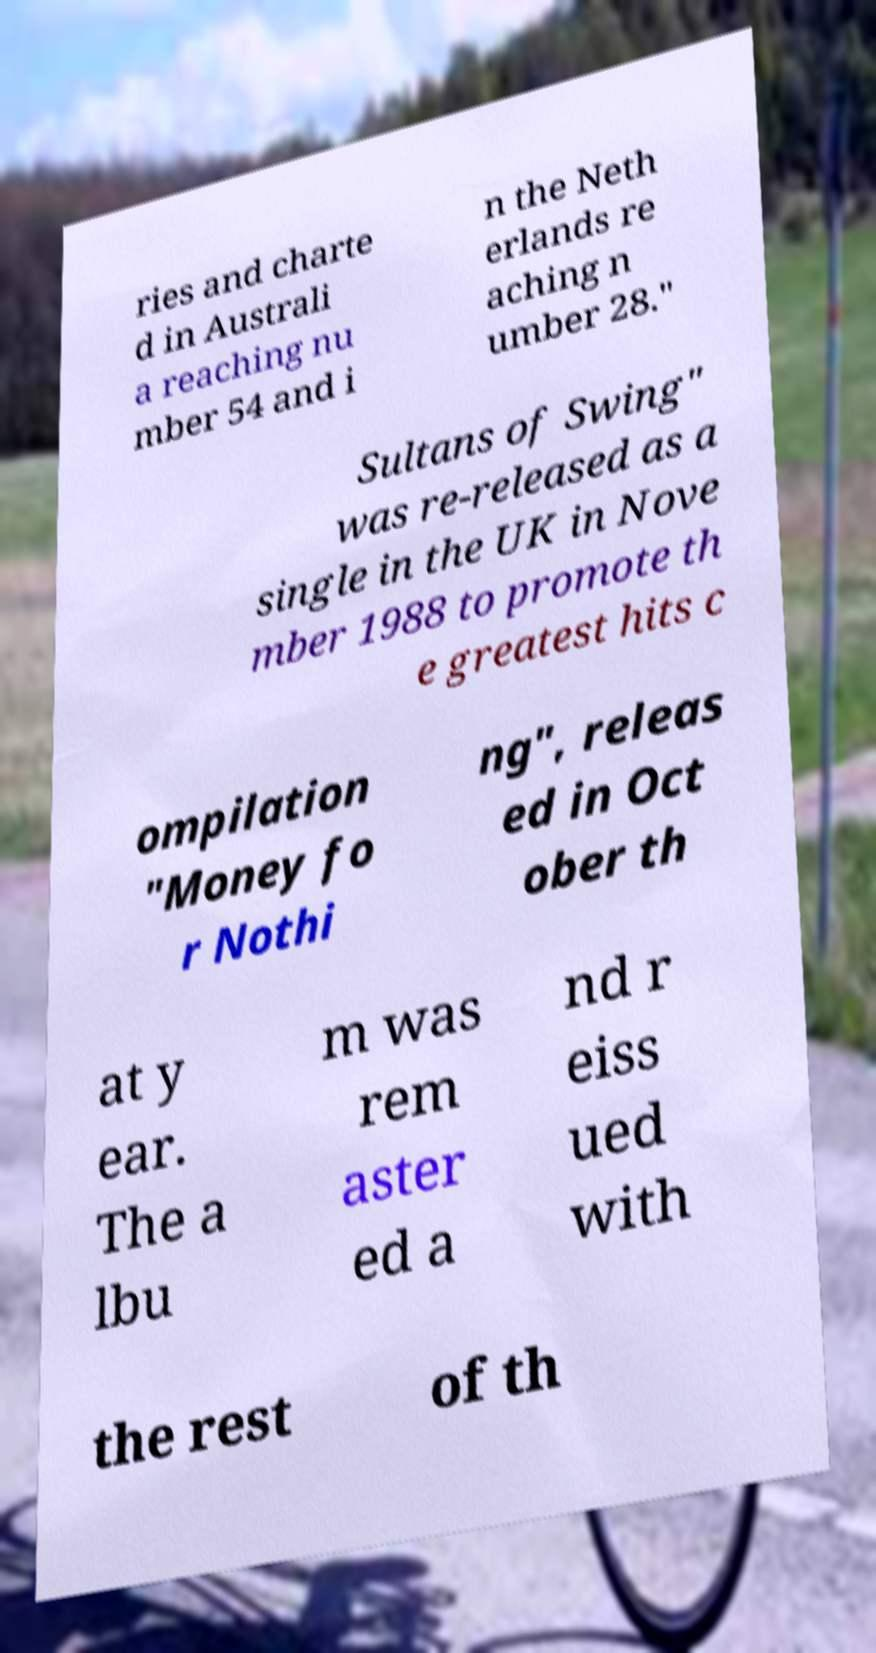Could you extract and type out the text from this image? ries and charte d in Australi a reaching nu mber 54 and i n the Neth erlands re aching n umber 28." Sultans of Swing" was re-released as a single in the UK in Nove mber 1988 to promote th e greatest hits c ompilation "Money fo r Nothi ng", releas ed in Oct ober th at y ear. The a lbu m was rem aster ed a nd r eiss ued with the rest of th 